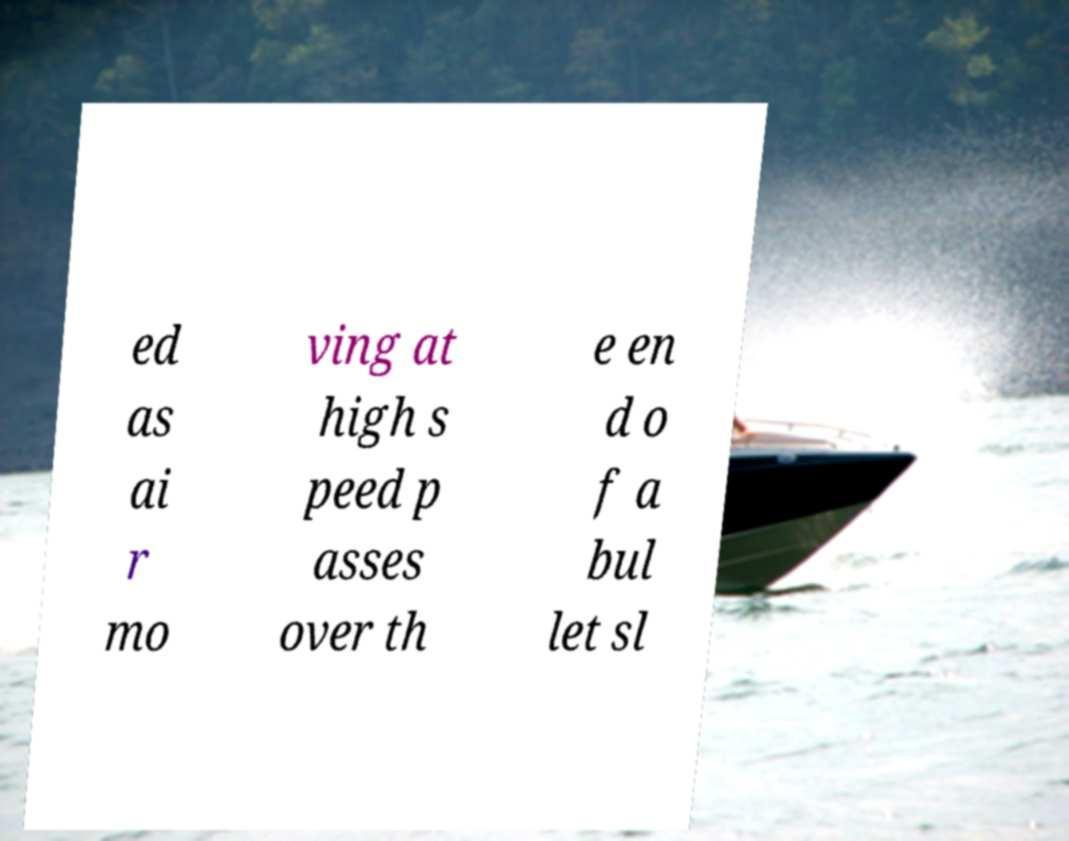Could you extract and type out the text from this image? ed as ai r mo ving at high s peed p asses over th e en d o f a bul let sl 